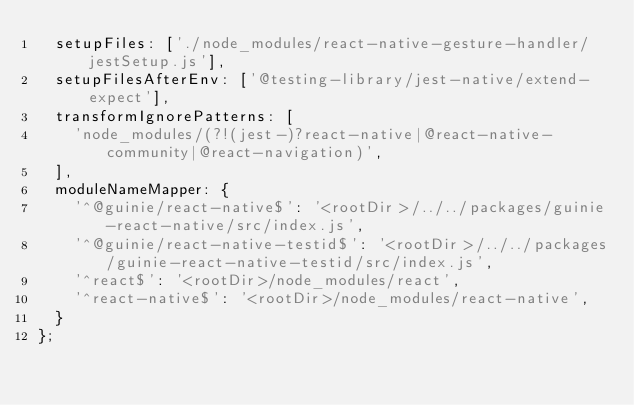Convert code to text. <code><loc_0><loc_0><loc_500><loc_500><_JavaScript_>  setupFiles: ['./node_modules/react-native-gesture-handler/jestSetup.js'],
  setupFilesAfterEnv: ['@testing-library/jest-native/extend-expect'],
  transformIgnorePatterns: [
    'node_modules/(?!(jest-)?react-native|@react-native-community|@react-navigation)',
  ],
  moduleNameMapper: {
    '^@guinie/react-native$': '<rootDir>/../../packages/guinie-react-native/src/index.js',
    '^@guinie/react-native-testid$': '<rootDir>/../../packages/guinie-react-native-testid/src/index.js',
    '^react$': '<rootDir>/node_modules/react',
    '^react-native$': '<rootDir>/node_modules/react-native',
  }
};
</code> 